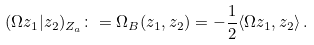<formula> <loc_0><loc_0><loc_500><loc_500>( \Omega z _ { 1 } | z _ { 2 } ) _ { Z _ { a } } \colon = \Omega _ { B } ( z _ { 1 } , z _ { 2 } ) = - \frac { 1 } { 2 } \langle \Omega z _ { 1 } , z _ { 2 } \rangle \, .</formula> 